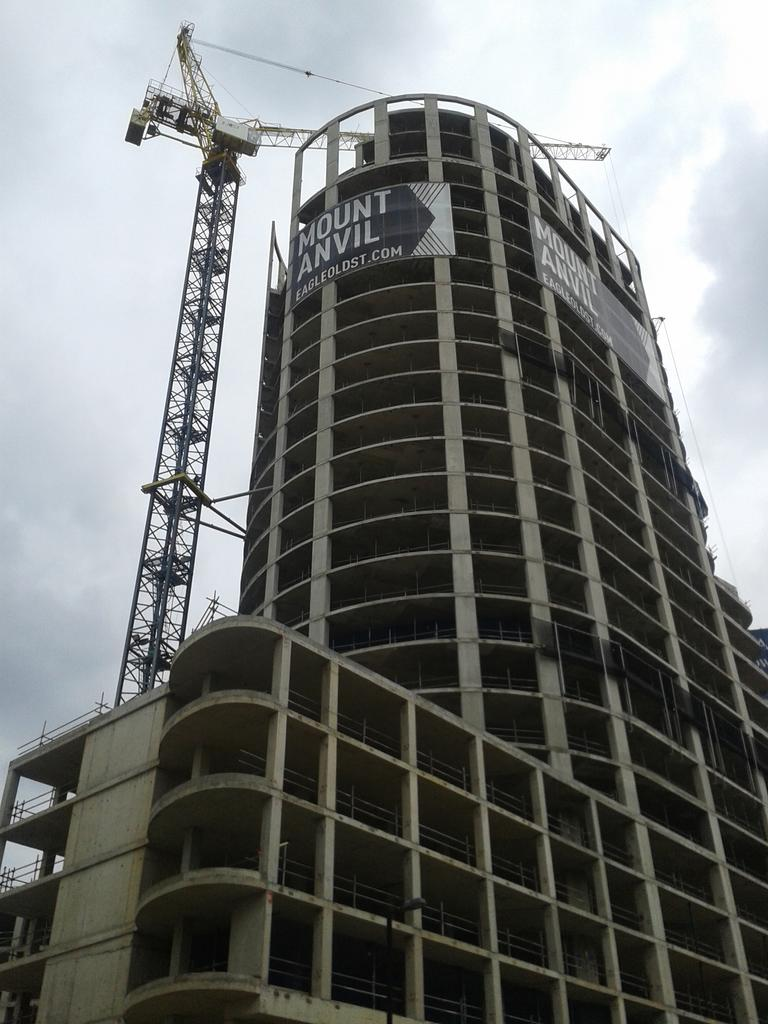What type of structure can be seen in the image? There is a construction building in the image. What equipment is visible at the construction site? A crane is present in the image. How would you describe the weather based on the image? The sky is cloudy in the image. What type of bait is being used to catch fish in the image? There is no indication of fishing or bait in the image; it features a construction building and a crane. Can you see the heart of the construction worker in the image? The image does not show any people, so it is impossible to see the heart of a construction worker. 